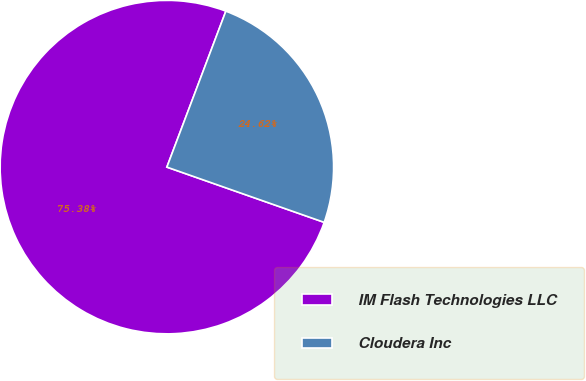<chart> <loc_0><loc_0><loc_500><loc_500><pie_chart><fcel>IM Flash Technologies LLC<fcel>Cloudera Inc<nl><fcel>75.38%<fcel>24.62%<nl></chart> 